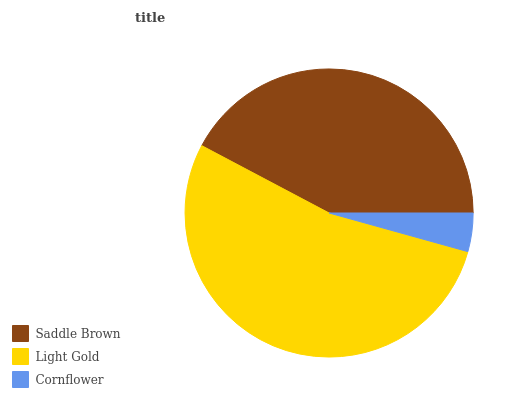Is Cornflower the minimum?
Answer yes or no. Yes. Is Light Gold the maximum?
Answer yes or no. Yes. Is Light Gold the minimum?
Answer yes or no. No. Is Cornflower the maximum?
Answer yes or no. No. Is Light Gold greater than Cornflower?
Answer yes or no. Yes. Is Cornflower less than Light Gold?
Answer yes or no. Yes. Is Cornflower greater than Light Gold?
Answer yes or no. No. Is Light Gold less than Cornflower?
Answer yes or no. No. Is Saddle Brown the high median?
Answer yes or no. Yes. Is Saddle Brown the low median?
Answer yes or no. Yes. Is Cornflower the high median?
Answer yes or no. No. Is Light Gold the low median?
Answer yes or no. No. 